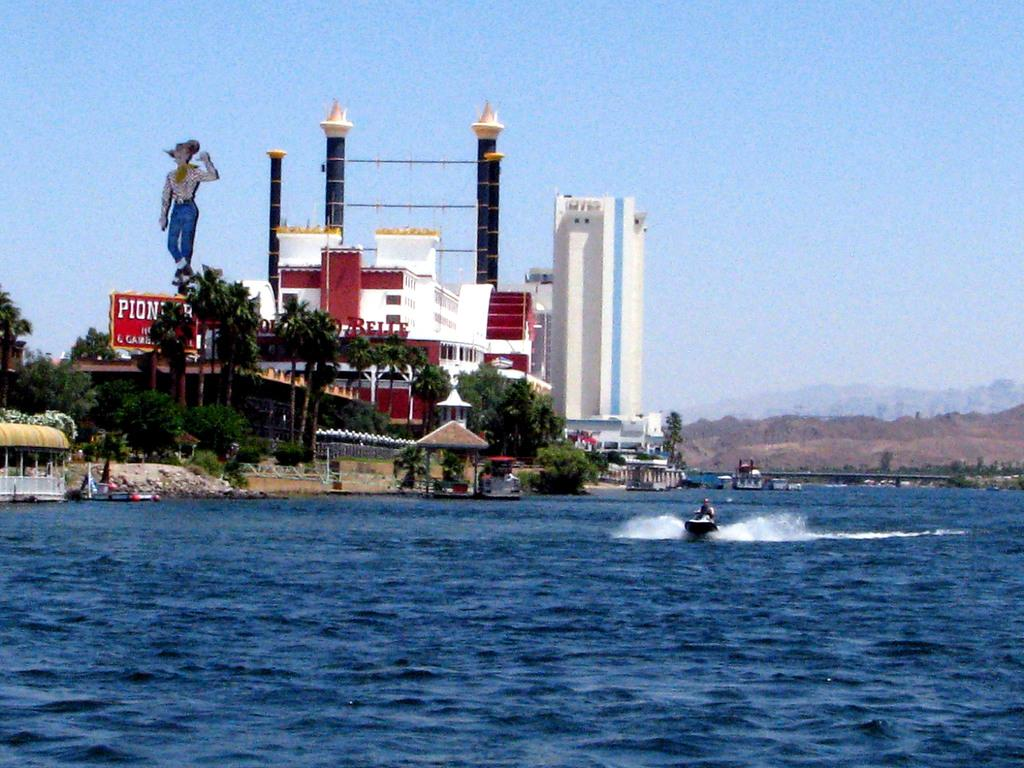What is the main structure in the center of the image? There is a building in the center of the image. What type of natural elements can be seen in the image? There are trees and water visible in the image. What is floating on the water in the image? A boat is present on the water. What part of the natural environment is visible in the background of the image? The sky is visible in the background of the image. What type of quince dish is being served for lunch in the image? There is no mention of lunch or quince in the image; it features a building, trees, water, a boat, and the sky. 